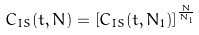Convert formula to latex. <formula><loc_0><loc_0><loc_500><loc_500>C _ { I S } ( t , N ) = \left [ C _ { I S } ( t , N _ { 1 } ) \right ] ^ { \frac { N } { N _ { 1 } } }</formula> 